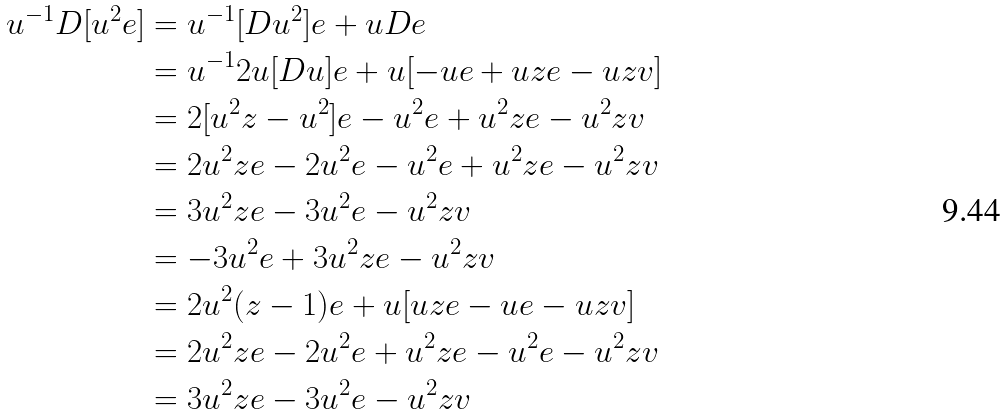Convert formula to latex. <formula><loc_0><loc_0><loc_500><loc_500>u ^ { - 1 } D [ { u ^ { 2 } } { e } ] & = u ^ { - 1 } [ D u ^ { 2 } ] e + u D e \\ & = u ^ { - 1 } 2 u [ D u ] e + u [ - u e + u z e - u z v ] \\ & = 2 [ u ^ { 2 } z - u ^ { 2 } ] e - u ^ { 2 } e + u ^ { 2 } z e - u ^ { 2 } z v \\ & = 2 u ^ { 2 } z e - 2 u ^ { 2 } e - u ^ { 2 } e + u ^ { 2 } z e - u ^ { 2 } z v \\ & = 3 u ^ { 2 } z e - 3 u ^ { 2 } e - u ^ { 2 } z v \\ & = - 3 u ^ { 2 } e + 3 u ^ { 2 } z e - u ^ { 2 } z v \\ & = 2 u ^ { 2 } ( z - 1 ) e + u [ u z e - u e - u z v ] \\ & = 2 u ^ { 2 } z e - 2 u ^ { 2 } e + u ^ { 2 } z e - u ^ { 2 } e - u ^ { 2 } z v \\ & = 3 u ^ { 2 } z e - 3 u ^ { 2 } e - u ^ { 2 } z v \\</formula> 